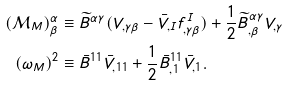Convert formula to latex. <formula><loc_0><loc_0><loc_500><loc_500>( { \mathcal { M } } _ { M } ) ^ { \alpha } _ { \beta } & \equiv \widetilde { B } ^ { \alpha \gamma } ( V _ { , \gamma \beta } - \bar { V } _ { , I } f ^ { I } _ { , \gamma \beta } ) + \frac { 1 } { 2 } \widetilde { B } ^ { \alpha \gamma } _ { , \beta } V _ { , \gamma } \\ ( \omega _ { M } ) ^ { 2 } & \equiv \bar { B } ^ { 1 1 } \bar { V } _ { , 1 1 } + \frac { 1 } { 2 } \bar { B } ^ { 1 1 } _ { , 1 } \bar { V } _ { , 1 } .</formula> 